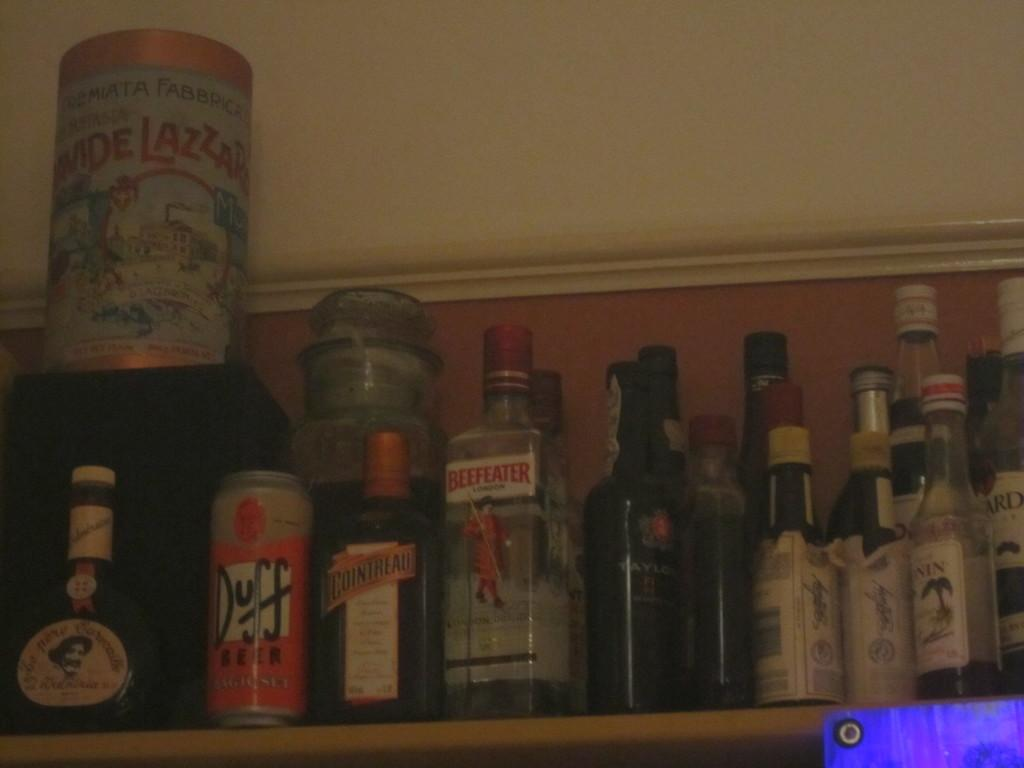<image>
Offer a succinct explanation of the picture presented. a beer can with the name Duff on it 